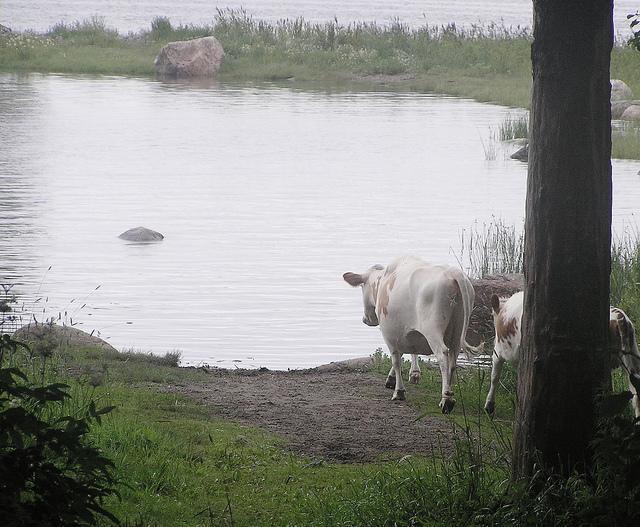How many trees can you see?
Give a very brief answer. 1. How many cows are there?
Give a very brief answer. 2. 